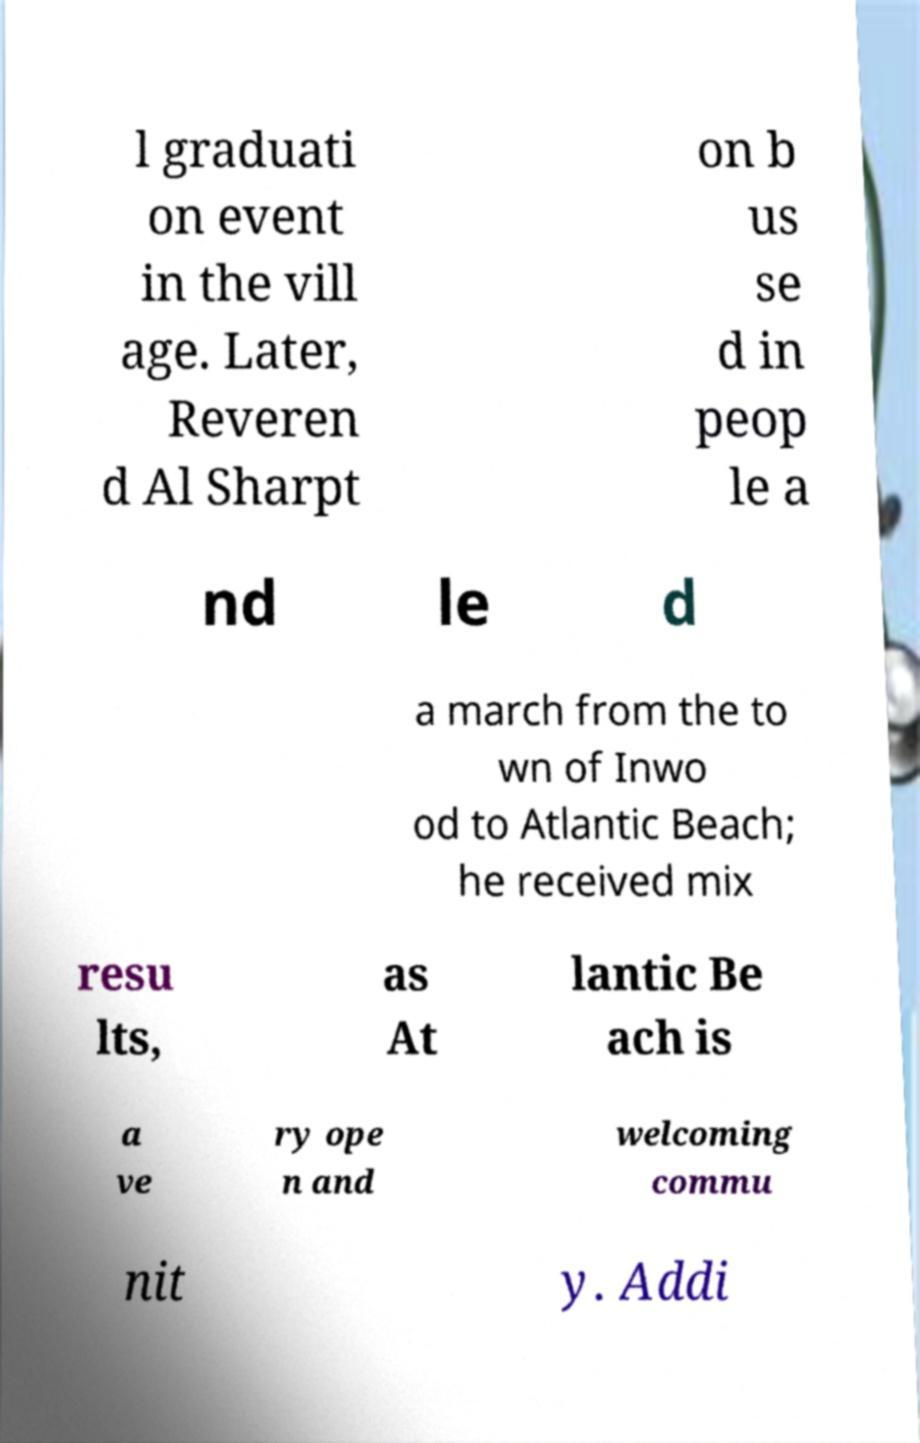For documentation purposes, I need the text within this image transcribed. Could you provide that? l graduati on event in the vill age. Later, Reveren d Al Sharpt on b us se d in peop le a nd le d a march from the to wn of Inwo od to Atlantic Beach; he received mix resu lts, as At lantic Be ach is a ve ry ope n and welcoming commu nit y. Addi 